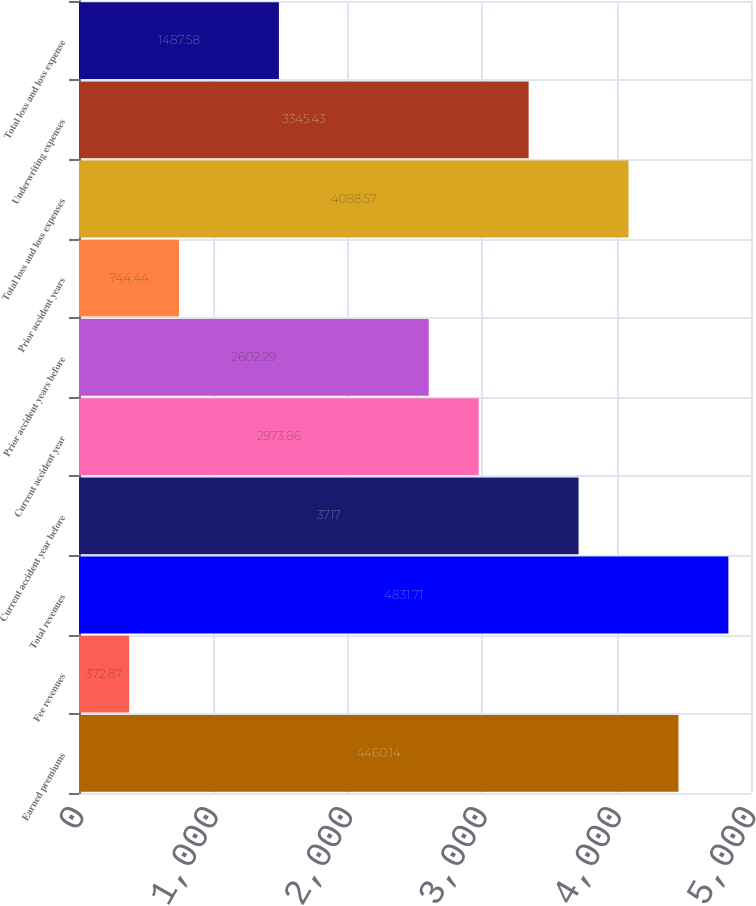Convert chart to OTSL. <chart><loc_0><loc_0><loc_500><loc_500><bar_chart><fcel>Earned premiums<fcel>Fee revenues<fcel>Total revenues<fcel>Current accident year before<fcel>Current accident year<fcel>Prior accident years before<fcel>Prior accident years<fcel>Total loss and loss expenses<fcel>Underwriting expenses<fcel>Total loss and loss expense<nl><fcel>4460.14<fcel>372.87<fcel>4831.71<fcel>3717<fcel>2973.86<fcel>2602.29<fcel>744.44<fcel>4088.57<fcel>3345.43<fcel>1487.58<nl></chart> 